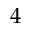<formula> <loc_0><loc_0><loc_500><loc_500>4</formula> 